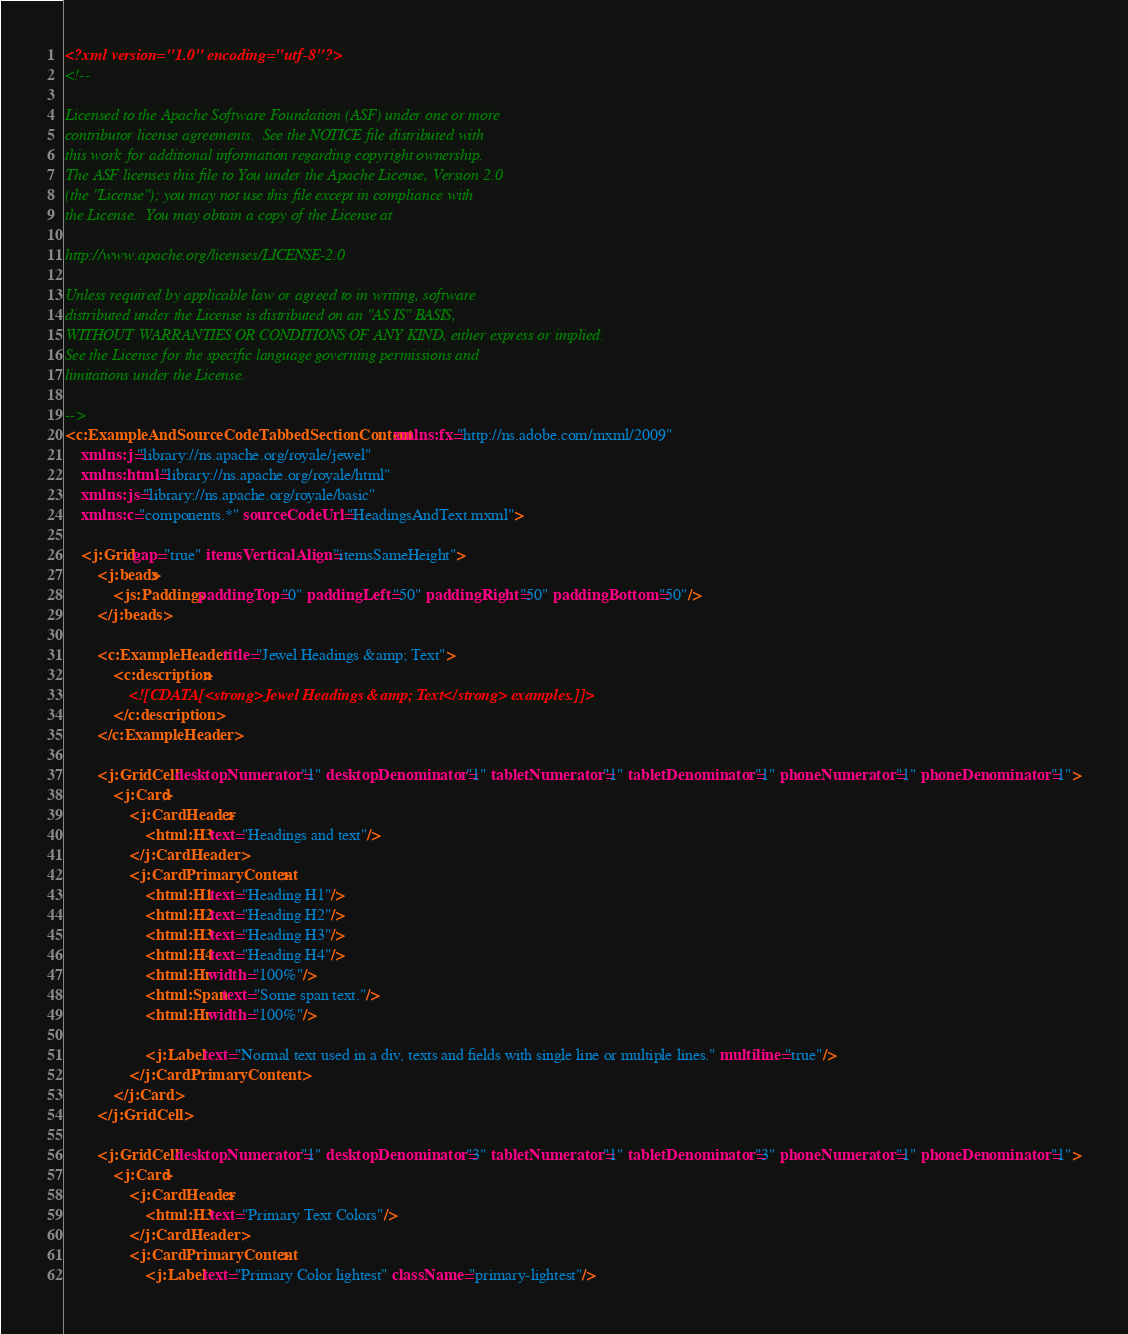<code> <loc_0><loc_0><loc_500><loc_500><_XML_><?xml version="1.0" encoding="utf-8"?>
<!--

Licensed to the Apache Software Foundation (ASF) under one or more
contributor license agreements.  See the NOTICE file distributed with
this work for additional information regarding copyright ownership.
The ASF licenses this file to You under the Apache License, Version 2.0
(the "License"); you may not use this file except in compliance with
the License.  You may obtain a copy of the License at

http://www.apache.org/licenses/LICENSE-2.0

Unless required by applicable law or agreed to in writing, software
distributed under the License is distributed on an "AS IS" BASIS,
WITHOUT WARRANTIES OR CONDITIONS OF ANY KIND, either express or implied.
See the License for the specific language governing permissions and
limitations under the License.

-->
<c:ExampleAndSourceCodeTabbedSectionContent xmlns:fx="http://ns.adobe.com/mxml/2009" 
	xmlns:j="library://ns.apache.org/royale/jewel" 
	xmlns:html="library://ns.apache.org/royale/html" 
	xmlns:js="library://ns.apache.org/royale/basic" 
	xmlns:c="components.*" sourceCodeUrl="HeadingsAndText.mxml">
	
	<j:Grid gap="true" itemsVerticalAlign="itemsSameHeight">
		<j:beads>
			<js:Paddings paddingTop="0" paddingLeft="50" paddingRight="50" paddingBottom="50"/>
		</j:beads>
		
		<c:ExampleHeader title="Jewel Headings &amp; Text">
			<c:description>
				<![CDATA[<strong>Jewel Headings &amp; Text</strong> examples.]]>
			</c:description>
		</c:ExampleHeader>

		<j:GridCell desktopNumerator="1" desktopDenominator="1" tabletNumerator="1" tabletDenominator="1" phoneNumerator="1" phoneDenominator="1">
            <j:Card>
				<j:CardHeader>
					<html:H3 text="Headings and text"/>
				</j:CardHeader>
				<j:CardPrimaryContent>
					<html:H1 text="Heading H1"/>
					<html:H2 text="Heading H2"/>
					<html:H3 text="Heading H3"/>
					<html:H4 text="Heading H4"/>
					<html:Hr width="100%"/>
					<html:Span text="Some span text."/>
					<html:Hr width="100%"/>

					<j:Label text="Normal text used in a div, texts and fields with single line or multiple lines." multiline="true"/>
				</j:CardPrimaryContent>
			</j:Card>
        </j:GridCell>
		
		<j:GridCell desktopNumerator="1" desktopDenominator="3" tabletNumerator="1" tabletDenominator="3" phoneNumerator="1" phoneDenominator="1">
            <j:Card>
				<j:CardHeader>
					<html:H3 text="Primary Text Colors"/>
				</j:CardHeader>
				<j:CardPrimaryContent>
					<j:Label text="Primary Color lightest" className="primary-lightest"/></code> 